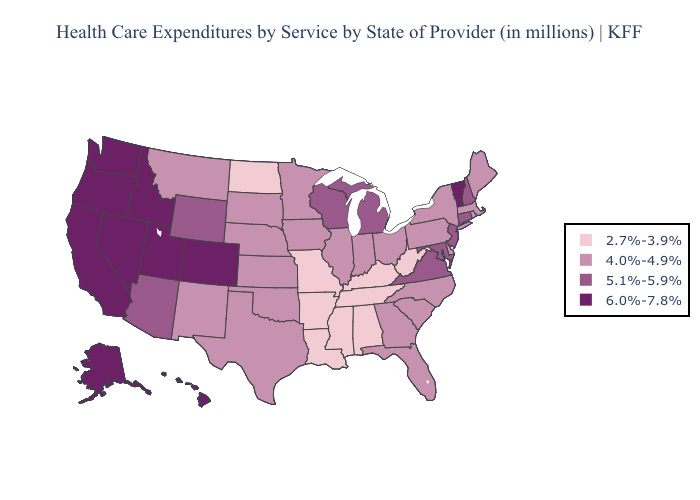Does Kansas have a higher value than Delaware?
Short answer required. No. Name the states that have a value in the range 5.1%-5.9%?
Keep it brief. Arizona, Connecticut, Maryland, Michigan, New Hampshire, New Jersey, Virginia, Wisconsin, Wyoming. Does Montana have the same value as Wyoming?
Short answer required. No. What is the lowest value in the MidWest?
Quick response, please. 2.7%-3.9%. What is the highest value in the Northeast ?
Write a very short answer. 6.0%-7.8%. Among the states that border Maine , which have the highest value?
Concise answer only. New Hampshire. Which states have the highest value in the USA?
Short answer required. Alaska, California, Colorado, Hawaii, Idaho, Nevada, Oregon, Utah, Vermont, Washington. Among the states that border North Carolina , which have the highest value?
Quick response, please. Virginia. What is the value of Florida?
Give a very brief answer. 4.0%-4.9%. Which states have the highest value in the USA?
Quick response, please. Alaska, California, Colorado, Hawaii, Idaho, Nevada, Oregon, Utah, Vermont, Washington. Does Nevada have the highest value in the USA?
Answer briefly. Yes. What is the value of Oregon?
Give a very brief answer. 6.0%-7.8%. Which states hav the highest value in the South?
Write a very short answer. Maryland, Virginia. Does Nevada have the same value as Colorado?
Quick response, please. Yes. Does Arkansas have the lowest value in the USA?
Answer briefly. Yes. 